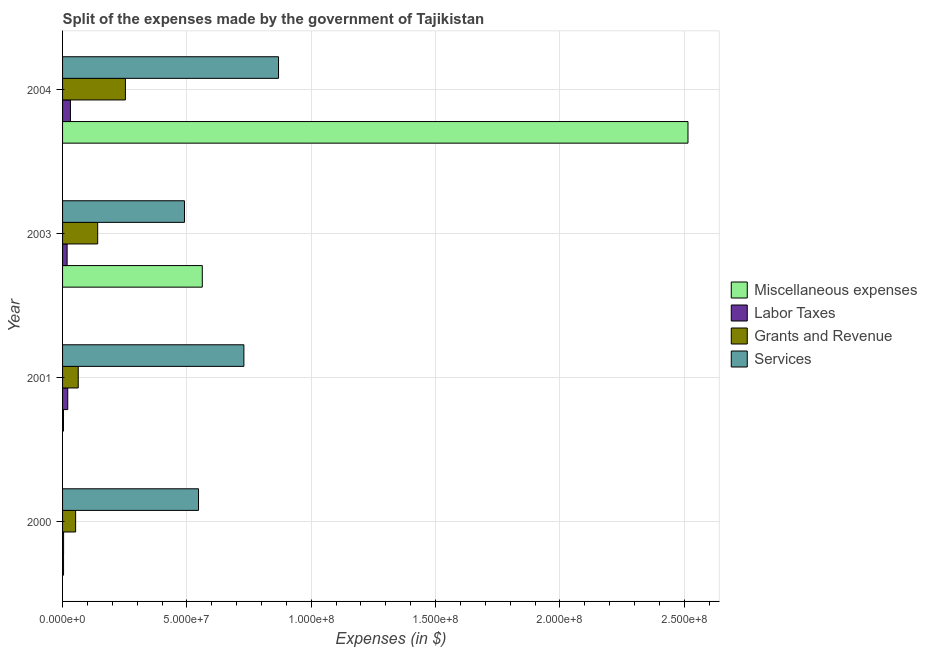How many different coloured bars are there?
Provide a succinct answer. 4. How many groups of bars are there?
Ensure brevity in your answer.  4. In how many cases, is the number of bars for a given year not equal to the number of legend labels?
Give a very brief answer. 0. What is the amount spent on services in 2000?
Keep it short and to the point. 5.47e+07. Across all years, what is the maximum amount spent on grants and revenue?
Keep it short and to the point. 2.53e+07. Across all years, what is the minimum amount spent on grants and revenue?
Your answer should be very brief. 5.25e+06. In which year was the amount spent on services minimum?
Provide a succinct answer. 2003. What is the total amount spent on grants and revenue in the graph?
Your answer should be compact. 5.10e+07. What is the difference between the amount spent on miscellaneous expenses in 2003 and that in 2004?
Your response must be concise. -1.95e+08. What is the difference between the amount spent on grants and revenue in 2003 and the amount spent on miscellaneous expenses in 2004?
Your response must be concise. -2.37e+08. What is the average amount spent on grants and revenue per year?
Provide a succinct answer. 1.27e+07. In the year 2000, what is the difference between the amount spent on services and amount spent on miscellaneous expenses?
Your response must be concise. 5.43e+07. What is the ratio of the amount spent on labor taxes in 2001 to that in 2004?
Give a very brief answer. 0.66. What is the difference between the highest and the second highest amount spent on labor taxes?
Ensure brevity in your answer.  1.08e+06. What is the difference between the highest and the lowest amount spent on grants and revenue?
Your response must be concise. 2.00e+07. In how many years, is the amount spent on services greater than the average amount spent on services taken over all years?
Offer a very short reply. 2. Is it the case that in every year, the sum of the amount spent on grants and revenue and amount spent on miscellaneous expenses is greater than the sum of amount spent on labor taxes and amount spent on services?
Give a very brief answer. No. What does the 1st bar from the top in 2000 represents?
Give a very brief answer. Services. What does the 1st bar from the bottom in 2004 represents?
Give a very brief answer. Miscellaneous expenses. Is it the case that in every year, the sum of the amount spent on miscellaneous expenses and amount spent on labor taxes is greater than the amount spent on grants and revenue?
Offer a very short reply. No. Are all the bars in the graph horizontal?
Provide a short and direct response. Yes. Are the values on the major ticks of X-axis written in scientific E-notation?
Provide a succinct answer. Yes. How many legend labels are there?
Your response must be concise. 4. How are the legend labels stacked?
Provide a succinct answer. Vertical. What is the title of the graph?
Your response must be concise. Split of the expenses made by the government of Tajikistan. What is the label or title of the X-axis?
Ensure brevity in your answer.  Expenses (in $). What is the label or title of the Y-axis?
Offer a terse response. Year. What is the Expenses (in $) of Miscellaneous expenses in 2000?
Offer a very short reply. 3.95e+05. What is the Expenses (in $) of Labor Taxes in 2000?
Your response must be concise. 4.11e+05. What is the Expenses (in $) of Grants and Revenue in 2000?
Make the answer very short. 5.25e+06. What is the Expenses (in $) of Services in 2000?
Offer a very short reply. 5.47e+07. What is the Expenses (in $) in Miscellaneous expenses in 2001?
Provide a short and direct response. 3.70e+05. What is the Expenses (in $) in Labor Taxes in 2001?
Make the answer very short. 2.09e+06. What is the Expenses (in $) of Grants and Revenue in 2001?
Provide a succinct answer. 6.30e+06. What is the Expenses (in $) in Services in 2001?
Your answer should be very brief. 7.29e+07. What is the Expenses (in $) of Miscellaneous expenses in 2003?
Give a very brief answer. 5.62e+07. What is the Expenses (in $) of Labor Taxes in 2003?
Offer a very short reply. 1.83e+06. What is the Expenses (in $) of Grants and Revenue in 2003?
Offer a very short reply. 1.41e+07. What is the Expenses (in $) of Services in 2003?
Keep it short and to the point. 4.90e+07. What is the Expenses (in $) in Miscellaneous expenses in 2004?
Your response must be concise. 2.51e+08. What is the Expenses (in $) in Labor Taxes in 2004?
Your response must be concise. 3.17e+06. What is the Expenses (in $) of Grants and Revenue in 2004?
Provide a succinct answer. 2.53e+07. What is the Expenses (in $) of Services in 2004?
Ensure brevity in your answer.  8.68e+07. Across all years, what is the maximum Expenses (in $) of Miscellaneous expenses?
Provide a short and direct response. 2.51e+08. Across all years, what is the maximum Expenses (in $) of Labor Taxes?
Offer a very short reply. 3.17e+06. Across all years, what is the maximum Expenses (in $) of Grants and Revenue?
Offer a very short reply. 2.53e+07. Across all years, what is the maximum Expenses (in $) in Services?
Make the answer very short. 8.68e+07. Across all years, what is the minimum Expenses (in $) in Labor Taxes?
Your answer should be compact. 4.11e+05. Across all years, what is the minimum Expenses (in $) of Grants and Revenue?
Offer a terse response. 5.25e+06. Across all years, what is the minimum Expenses (in $) in Services?
Your response must be concise. 4.90e+07. What is the total Expenses (in $) of Miscellaneous expenses in the graph?
Offer a very short reply. 3.08e+08. What is the total Expenses (in $) in Labor Taxes in the graph?
Offer a very short reply. 7.50e+06. What is the total Expenses (in $) in Grants and Revenue in the graph?
Your response must be concise. 5.10e+07. What is the total Expenses (in $) of Services in the graph?
Keep it short and to the point. 2.63e+08. What is the difference between the Expenses (in $) in Miscellaneous expenses in 2000 and that in 2001?
Make the answer very short. 2.50e+04. What is the difference between the Expenses (in $) of Labor Taxes in 2000 and that in 2001?
Offer a terse response. -1.68e+06. What is the difference between the Expenses (in $) in Grants and Revenue in 2000 and that in 2001?
Keep it short and to the point. -1.05e+06. What is the difference between the Expenses (in $) of Services in 2000 and that in 2001?
Offer a very short reply. -1.82e+07. What is the difference between the Expenses (in $) of Miscellaneous expenses in 2000 and that in 2003?
Ensure brevity in your answer.  -5.58e+07. What is the difference between the Expenses (in $) of Labor Taxes in 2000 and that in 2003?
Your response must be concise. -1.42e+06. What is the difference between the Expenses (in $) in Grants and Revenue in 2000 and that in 2003?
Provide a short and direct response. -8.87e+06. What is the difference between the Expenses (in $) of Services in 2000 and that in 2003?
Your answer should be compact. 5.65e+06. What is the difference between the Expenses (in $) in Miscellaneous expenses in 2000 and that in 2004?
Your answer should be very brief. -2.51e+08. What is the difference between the Expenses (in $) of Labor Taxes in 2000 and that in 2004?
Give a very brief answer. -2.76e+06. What is the difference between the Expenses (in $) in Grants and Revenue in 2000 and that in 2004?
Your answer should be very brief. -2.00e+07. What is the difference between the Expenses (in $) in Services in 2000 and that in 2004?
Provide a short and direct response. -3.22e+07. What is the difference between the Expenses (in $) of Miscellaneous expenses in 2001 and that in 2003?
Make the answer very short. -5.58e+07. What is the difference between the Expenses (in $) in Labor Taxes in 2001 and that in 2003?
Provide a short and direct response. 2.58e+05. What is the difference between the Expenses (in $) in Grants and Revenue in 2001 and that in 2003?
Your response must be concise. -7.82e+06. What is the difference between the Expenses (in $) in Services in 2001 and that in 2003?
Provide a short and direct response. 2.39e+07. What is the difference between the Expenses (in $) of Miscellaneous expenses in 2001 and that in 2004?
Keep it short and to the point. -2.51e+08. What is the difference between the Expenses (in $) of Labor Taxes in 2001 and that in 2004?
Offer a very short reply. -1.08e+06. What is the difference between the Expenses (in $) in Grants and Revenue in 2001 and that in 2004?
Offer a very short reply. -1.90e+07. What is the difference between the Expenses (in $) in Services in 2001 and that in 2004?
Your response must be concise. -1.39e+07. What is the difference between the Expenses (in $) of Miscellaneous expenses in 2003 and that in 2004?
Offer a very short reply. -1.95e+08. What is the difference between the Expenses (in $) in Labor Taxes in 2003 and that in 2004?
Make the answer very short. -1.34e+06. What is the difference between the Expenses (in $) of Grants and Revenue in 2003 and that in 2004?
Your answer should be very brief. -1.12e+07. What is the difference between the Expenses (in $) in Services in 2003 and that in 2004?
Provide a succinct answer. -3.78e+07. What is the difference between the Expenses (in $) of Miscellaneous expenses in 2000 and the Expenses (in $) of Labor Taxes in 2001?
Offer a terse response. -1.69e+06. What is the difference between the Expenses (in $) of Miscellaneous expenses in 2000 and the Expenses (in $) of Grants and Revenue in 2001?
Give a very brief answer. -5.90e+06. What is the difference between the Expenses (in $) of Miscellaneous expenses in 2000 and the Expenses (in $) of Services in 2001?
Offer a very short reply. -7.25e+07. What is the difference between the Expenses (in $) in Labor Taxes in 2000 and the Expenses (in $) in Grants and Revenue in 2001?
Give a very brief answer. -5.89e+06. What is the difference between the Expenses (in $) of Labor Taxes in 2000 and the Expenses (in $) of Services in 2001?
Provide a succinct answer. -7.25e+07. What is the difference between the Expenses (in $) in Grants and Revenue in 2000 and the Expenses (in $) in Services in 2001?
Your answer should be very brief. -6.77e+07. What is the difference between the Expenses (in $) of Miscellaneous expenses in 2000 and the Expenses (in $) of Labor Taxes in 2003?
Give a very brief answer. -1.43e+06. What is the difference between the Expenses (in $) of Miscellaneous expenses in 2000 and the Expenses (in $) of Grants and Revenue in 2003?
Your answer should be very brief. -1.37e+07. What is the difference between the Expenses (in $) of Miscellaneous expenses in 2000 and the Expenses (in $) of Services in 2003?
Ensure brevity in your answer.  -4.86e+07. What is the difference between the Expenses (in $) of Labor Taxes in 2000 and the Expenses (in $) of Grants and Revenue in 2003?
Provide a succinct answer. -1.37e+07. What is the difference between the Expenses (in $) of Labor Taxes in 2000 and the Expenses (in $) of Services in 2003?
Offer a terse response. -4.86e+07. What is the difference between the Expenses (in $) in Grants and Revenue in 2000 and the Expenses (in $) in Services in 2003?
Give a very brief answer. -4.38e+07. What is the difference between the Expenses (in $) of Miscellaneous expenses in 2000 and the Expenses (in $) of Labor Taxes in 2004?
Give a very brief answer. -2.78e+06. What is the difference between the Expenses (in $) in Miscellaneous expenses in 2000 and the Expenses (in $) in Grants and Revenue in 2004?
Provide a short and direct response. -2.49e+07. What is the difference between the Expenses (in $) of Miscellaneous expenses in 2000 and the Expenses (in $) of Services in 2004?
Offer a terse response. -8.64e+07. What is the difference between the Expenses (in $) in Labor Taxes in 2000 and the Expenses (in $) in Grants and Revenue in 2004?
Offer a very short reply. -2.49e+07. What is the difference between the Expenses (in $) in Labor Taxes in 2000 and the Expenses (in $) in Services in 2004?
Offer a very short reply. -8.64e+07. What is the difference between the Expenses (in $) in Grants and Revenue in 2000 and the Expenses (in $) in Services in 2004?
Provide a short and direct response. -8.16e+07. What is the difference between the Expenses (in $) of Miscellaneous expenses in 2001 and the Expenses (in $) of Labor Taxes in 2003?
Give a very brief answer. -1.46e+06. What is the difference between the Expenses (in $) of Miscellaneous expenses in 2001 and the Expenses (in $) of Grants and Revenue in 2003?
Ensure brevity in your answer.  -1.38e+07. What is the difference between the Expenses (in $) in Miscellaneous expenses in 2001 and the Expenses (in $) in Services in 2003?
Keep it short and to the point. -4.86e+07. What is the difference between the Expenses (in $) in Labor Taxes in 2001 and the Expenses (in $) in Grants and Revenue in 2003?
Your response must be concise. -1.20e+07. What is the difference between the Expenses (in $) of Labor Taxes in 2001 and the Expenses (in $) of Services in 2003?
Offer a terse response. -4.69e+07. What is the difference between the Expenses (in $) of Grants and Revenue in 2001 and the Expenses (in $) of Services in 2003?
Make the answer very short. -4.27e+07. What is the difference between the Expenses (in $) of Miscellaneous expenses in 2001 and the Expenses (in $) of Labor Taxes in 2004?
Offer a terse response. -2.80e+06. What is the difference between the Expenses (in $) in Miscellaneous expenses in 2001 and the Expenses (in $) in Grants and Revenue in 2004?
Ensure brevity in your answer.  -2.49e+07. What is the difference between the Expenses (in $) of Miscellaneous expenses in 2001 and the Expenses (in $) of Services in 2004?
Your response must be concise. -8.65e+07. What is the difference between the Expenses (in $) in Labor Taxes in 2001 and the Expenses (in $) in Grants and Revenue in 2004?
Make the answer very short. -2.32e+07. What is the difference between the Expenses (in $) in Labor Taxes in 2001 and the Expenses (in $) in Services in 2004?
Your answer should be very brief. -8.48e+07. What is the difference between the Expenses (in $) of Grants and Revenue in 2001 and the Expenses (in $) of Services in 2004?
Offer a terse response. -8.05e+07. What is the difference between the Expenses (in $) in Miscellaneous expenses in 2003 and the Expenses (in $) in Labor Taxes in 2004?
Keep it short and to the point. 5.30e+07. What is the difference between the Expenses (in $) in Miscellaneous expenses in 2003 and the Expenses (in $) in Grants and Revenue in 2004?
Give a very brief answer. 3.09e+07. What is the difference between the Expenses (in $) in Miscellaneous expenses in 2003 and the Expenses (in $) in Services in 2004?
Provide a succinct answer. -3.07e+07. What is the difference between the Expenses (in $) in Labor Taxes in 2003 and the Expenses (in $) in Grants and Revenue in 2004?
Your response must be concise. -2.34e+07. What is the difference between the Expenses (in $) in Labor Taxes in 2003 and the Expenses (in $) in Services in 2004?
Your answer should be compact. -8.50e+07. What is the difference between the Expenses (in $) of Grants and Revenue in 2003 and the Expenses (in $) of Services in 2004?
Offer a terse response. -7.27e+07. What is the average Expenses (in $) in Miscellaneous expenses per year?
Give a very brief answer. 7.71e+07. What is the average Expenses (in $) of Labor Taxes per year?
Ensure brevity in your answer.  1.87e+06. What is the average Expenses (in $) of Grants and Revenue per year?
Offer a terse response. 1.27e+07. What is the average Expenses (in $) in Services per year?
Your answer should be compact. 6.59e+07. In the year 2000, what is the difference between the Expenses (in $) of Miscellaneous expenses and Expenses (in $) of Labor Taxes?
Offer a very short reply. -1.60e+04. In the year 2000, what is the difference between the Expenses (in $) in Miscellaneous expenses and Expenses (in $) in Grants and Revenue?
Ensure brevity in your answer.  -4.86e+06. In the year 2000, what is the difference between the Expenses (in $) of Miscellaneous expenses and Expenses (in $) of Services?
Make the answer very short. -5.43e+07. In the year 2000, what is the difference between the Expenses (in $) of Labor Taxes and Expenses (in $) of Grants and Revenue?
Your answer should be compact. -4.84e+06. In the year 2000, what is the difference between the Expenses (in $) of Labor Taxes and Expenses (in $) of Services?
Offer a very short reply. -5.43e+07. In the year 2000, what is the difference between the Expenses (in $) of Grants and Revenue and Expenses (in $) of Services?
Provide a short and direct response. -4.94e+07. In the year 2001, what is the difference between the Expenses (in $) in Miscellaneous expenses and Expenses (in $) in Labor Taxes?
Provide a succinct answer. -1.72e+06. In the year 2001, what is the difference between the Expenses (in $) of Miscellaneous expenses and Expenses (in $) of Grants and Revenue?
Keep it short and to the point. -5.93e+06. In the year 2001, what is the difference between the Expenses (in $) of Miscellaneous expenses and Expenses (in $) of Services?
Your response must be concise. -7.25e+07. In the year 2001, what is the difference between the Expenses (in $) in Labor Taxes and Expenses (in $) in Grants and Revenue?
Your answer should be very brief. -4.21e+06. In the year 2001, what is the difference between the Expenses (in $) of Labor Taxes and Expenses (in $) of Services?
Offer a very short reply. -7.08e+07. In the year 2001, what is the difference between the Expenses (in $) of Grants and Revenue and Expenses (in $) of Services?
Give a very brief answer. -6.66e+07. In the year 2003, what is the difference between the Expenses (in $) of Miscellaneous expenses and Expenses (in $) of Labor Taxes?
Provide a succinct answer. 5.44e+07. In the year 2003, what is the difference between the Expenses (in $) in Miscellaneous expenses and Expenses (in $) in Grants and Revenue?
Provide a succinct answer. 4.21e+07. In the year 2003, what is the difference between the Expenses (in $) in Miscellaneous expenses and Expenses (in $) in Services?
Offer a terse response. 7.16e+06. In the year 2003, what is the difference between the Expenses (in $) of Labor Taxes and Expenses (in $) of Grants and Revenue?
Keep it short and to the point. -1.23e+07. In the year 2003, what is the difference between the Expenses (in $) in Labor Taxes and Expenses (in $) in Services?
Offer a terse response. -4.72e+07. In the year 2003, what is the difference between the Expenses (in $) of Grants and Revenue and Expenses (in $) of Services?
Give a very brief answer. -3.49e+07. In the year 2004, what is the difference between the Expenses (in $) in Miscellaneous expenses and Expenses (in $) in Labor Taxes?
Offer a terse response. 2.48e+08. In the year 2004, what is the difference between the Expenses (in $) of Miscellaneous expenses and Expenses (in $) of Grants and Revenue?
Provide a short and direct response. 2.26e+08. In the year 2004, what is the difference between the Expenses (in $) of Miscellaneous expenses and Expenses (in $) of Services?
Provide a succinct answer. 1.65e+08. In the year 2004, what is the difference between the Expenses (in $) of Labor Taxes and Expenses (in $) of Grants and Revenue?
Give a very brief answer. -2.21e+07. In the year 2004, what is the difference between the Expenses (in $) in Labor Taxes and Expenses (in $) in Services?
Your answer should be very brief. -8.37e+07. In the year 2004, what is the difference between the Expenses (in $) of Grants and Revenue and Expenses (in $) of Services?
Your response must be concise. -6.16e+07. What is the ratio of the Expenses (in $) in Miscellaneous expenses in 2000 to that in 2001?
Your answer should be very brief. 1.07. What is the ratio of the Expenses (in $) of Labor Taxes in 2000 to that in 2001?
Make the answer very short. 0.2. What is the ratio of the Expenses (in $) in Grants and Revenue in 2000 to that in 2001?
Make the answer very short. 0.83. What is the ratio of the Expenses (in $) in Services in 2000 to that in 2001?
Offer a very short reply. 0.75. What is the ratio of the Expenses (in $) in Miscellaneous expenses in 2000 to that in 2003?
Keep it short and to the point. 0.01. What is the ratio of the Expenses (in $) in Labor Taxes in 2000 to that in 2003?
Keep it short and to the point. 0.22. What is the ratio of the Expenses (in $) of Grants and Revenue in 2000 to that in 2003?
Offer a very short reply. 0.37. What is the ratio of the Expenses (in $) in Services in 2000 to that in 2003?
Your answer should be very brief. 1.12. What is the ratio of the Expenses (in $) of Miscellaneous expenses in 2000 to that in 2004?
Give a very brief answer. 0. What is the ratio of the Expenses (in $) of Labor Taxes in 2000 to that in 2004?
Your answer should be very brief. 0.13. What is the ratio of the Expenses (in $) in Grants and Revenue in 2000 to that in 2004?
Keep it short and to the point. 0.21. What is the ratio of the Expenses (in $) in Services in 2000 to that in 2004?
Your answer should be compact. 0.63. What is the ratio of the Expenses (in $) of Miscellaneous expenses in 2001 to that in 2003?
Give a very brief answer. 0.01. What is the ratio of the Expenses (in $) of Labor Taxes in 2001 to that in 2003?
Ensure brevity in your answer.  1.14. What is the ratio of the Expenses (in $) in Grants and Revenue in 2001 to that in 2003?
Offer a very short reply. 0.45. What is the ratio of the Expenses (in $) in Services in 2001 to that in 2003?
Offer a terse response. 1.49. What is the ratio of the Expenses (in $) in Miscellaneous expenses in 2001 to that in 2004?
Your response must be concise. 0. What is the ratio of the Expenses (in $) in Labor Taxes in 2001 to that in 2004?
Provide a succinct answer. 0.66. What is the ratio of the Expenses (in $) in Grants and Revenue in 2001 to that in 2004?
Your answer should be very brief. 0.25. What is the ratio of the Expenses (in $) of Services in 2001 to that in 2004?
Your answer should be very brief. 0.84. What is the ratio of the Expenses (in $) in Miscellaneous expenses in 2003 to that in 2004?
Make the answer very short. 0.22. What is the ratio of the Expenses (in $) of Labor Taxes in 2003 to that in 2004?
Give a very brief answer. 0.58. What is the ratio of the Expenses (in $) in Grants and Revenue in 2003 to that in 2004?
Your response must be concise. 0.56. What is the ratio of the Expenses (in $) in Services in 2003 to that in 2004?
Provide a short and direct response. 0.56. What is the difference between the highest and the second highest Expenses (in $) in Miscellaneous expenses?
Provide a succinct answer. 1.95e+08. What is the difference between the highest and the second highest Expenses (in $) in Labor Taxes?
Keep it short and to the point. 1.08e+06. What is the difference between the highest and the second highest Expenses (in $) of Grants and Revenue?
Make the answer very short. 1.12e+07. What is the difference between the highest and the second highest Expenses (in $) of Services?
Provide a short and direct response. 1.39e+07. What is the difference between the highest and the lowest Expenses (in $) of Miscellaneous expenses?
Provide a short and direct response. 2.51e+08. What is the difference between the highest and the lowest Expenses (in $) in Labor Taxes?
Your response must be concise. 2.76e+06. What is the difference between the highest and the lowest Expenses (in $) in Grants and Revenue?
Ensure brevity in your answer.  2.00e+07. What is the difference between the highest and the lowest Expenses (in $) in Services?
Give a very brief answer. 3.78e+07. 